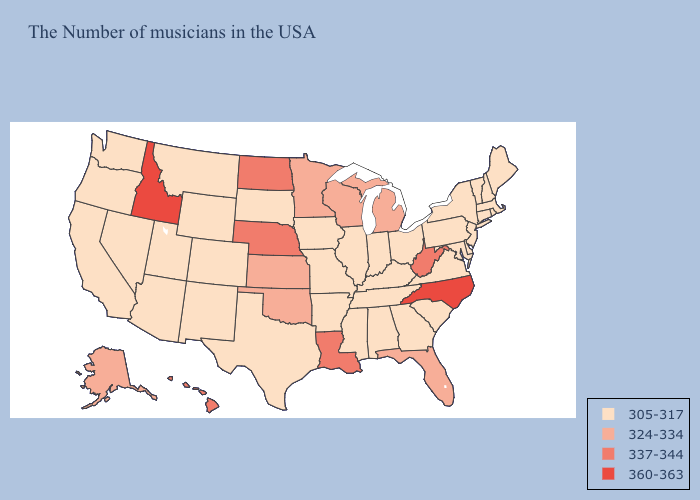What is the lowest value in states that border Idaho?
Write a very short answer. 305-317. What is the lowest value in states that border New Mexico?
Keep it brief. 305-317. Does North Dakota have the lowest value in the MidWest?
Give a very brief answer. No. What is the highest value in the South ?
Write a very short answer. 360-363. Name the states that have a value in the range 305-317?
Short answer required. Maine, Massachusetts, Rhode Island, New Hampshire, Vermont, Connecticut, New York, New Jersey, Delaware, Maryland, Pennsylvania, Virginia, South Carolina, Ohio, Georgia, Kentucky, Indiana, Alabama, Tennessee, Illinois, Mississippi, Missouri, Arkansas, Iowa, Texas, South Dakota, Wyoming, Colorado, New Mexico, Utah, Montana, Arizona, Nevada, California, Washington, Oregon. Does the map have missing data?
Give a very brief answer. No. Name the states that have a value in the range 305-317?
Keep it brief. Maine, Massachusetts, Rhode Island, New Hampshire, Vermont, Connecticut, New York, New Jersey, Delaware, Maryland, Pennsylvania, Virginia, South Carolina, Ohio, Georgia, Kentucky, Indiana, Alabama, Tennessee, Illinois, Mississippi, Missouri, Arkansas, Iowa, Texas, South Dakota, Wyoming, Colorado, New Mexico, Utah, Montana, Arizona, Nevada, California, Washington, Oregon. Does Nevada have a lower value than Maryland?
Keep it brief. No. What is the value of South Carolina?
Be succinct. 305-317. What is the value of Ohio?
Concise answer only. 305-317. Name the states that have a value in the range 337-344?
Quick response, please. West Virginia, Louisiana, Nebraska, North Dakota, Hawaii. What is the highest value in states that border Colorado?
Short answer required. 337-344. Does Illinois have a higher value than Hawaii?
Be succinct. No. Does Colorado have a higher value than Alabama?
Short answer required. No. Which states have the lowest value in the USA?
Answer briefly. Maine, Massachusetts, Rhode Island, New Hampshire, Vermont, Connecticut, New York, New Jersey, Delaware, Maryland, Pennsylvania, Virginia, South Carolina, Ohio, Georgia, Kentucky, Indiana, Alabama, Tennessee, Illinois, Mississippi, Missouri, Arkansas, Iowa, Texas, South Dakota, Wyoming, Colorado, New Mexico, Utah, Montana, Arizona, Nevada, California, Washington, Oregon. 